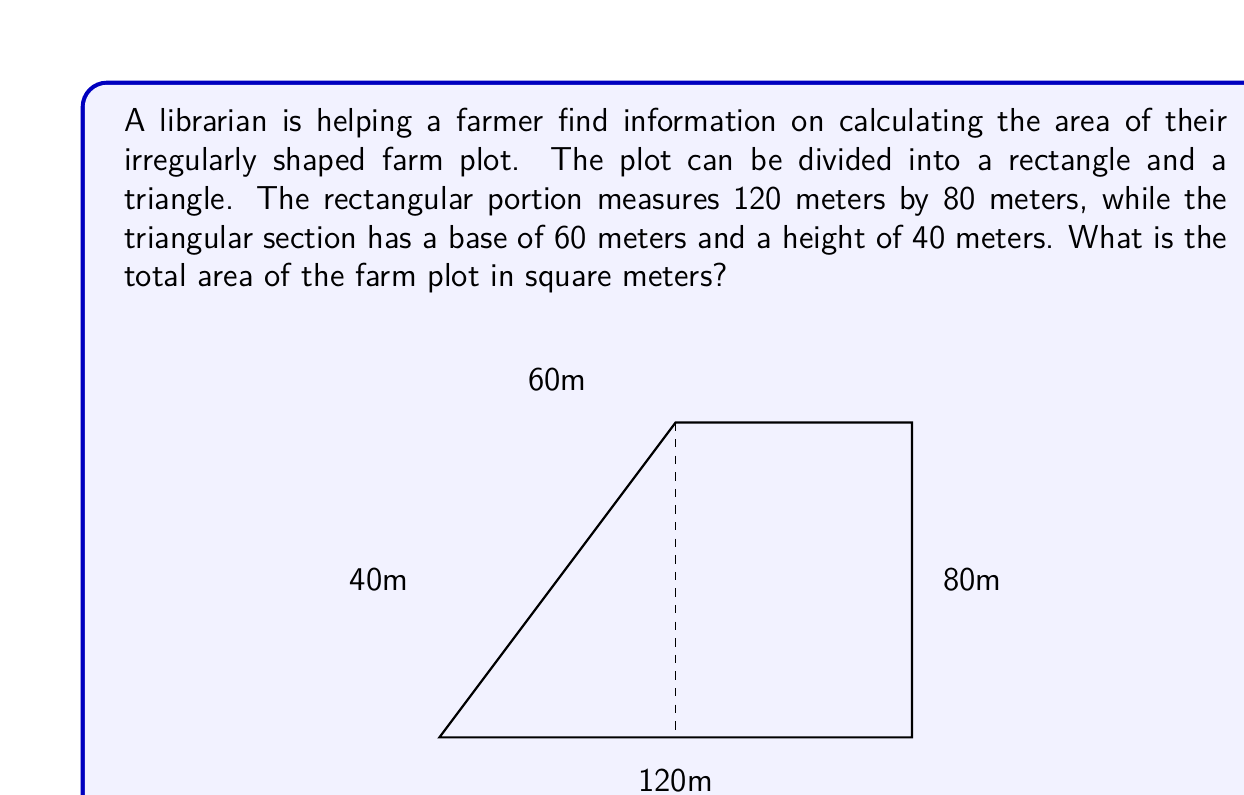Could you help me with this problem? To solve this problem, we need to calculate the areas of the rectangular and triangular portions separately, then add them together.

1. Area of the rectangle:
   $$A_r = l \times w$$
   where $l$ is length and $w$ is width.
   $$A_r = 120 \text{ m} \times 80 \text{ m} = 9,600 \text{ m}^2$$

2. Area of the triangle:
   $$A_t = \frac{1}{2} \times b \times h$$
   where $b$ is base and $h$ is height.
   $$A_t = \frac{1}{2} \times 60 \text{ m} \times 40 \text{ m} = 1,200 \text{ m}^2$$

3. Total area:
   $$A_{total} = A_r + A_t$$
   $$A_{total} = 9,600 \text{ m}^2 + 1,200 \text{ m}^2 = 10,800 \text{ m}^2$$
Answer: The total area of the farm plot is 10,800 square meters. 